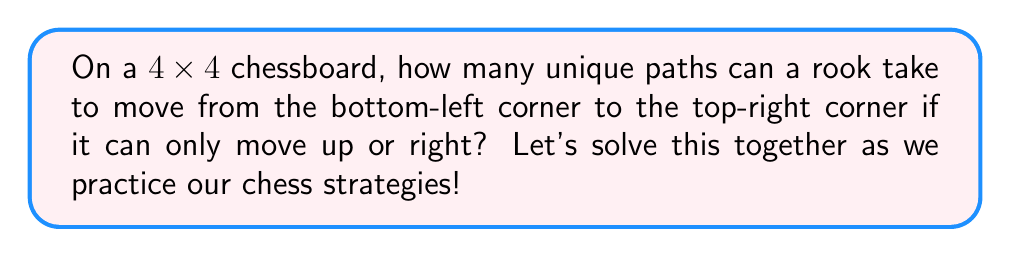Could you help me with this problem? Let's approach this step-by-step:

1) First, let's visualize the chessboard:

[asy]
size(100);
for(int i=0; i<4; ++i)
  for(int j=0; j<4; ++j)
    draw((i,j)--(i+1,j)--(i+1,j+1)--(i,j+1)--cycle);
dot((0,0), red);
dot((3,3), red);
label("Start", (0,0), SW);
label("End", (3,3), NE);
[/asy]

2) To reach the top-right corner from the bottom-left, the rook must move:
   - 3 steps right
   - 3 steps up

3) The total number of steps is always 6 (3 right + 3 up).

4) The question is essentially asking: in how many ways can we arrange 3 right moves and 3 up moves?

5) This is a combination problem. We need to choose 3 positions out of 6 for the right moves (or equivalently, for the up moves).

6) The formula for this combination is:

   $$\binom{6}{3} = \frac{6!}{3!(6-3)!} = \frac{6!}{3!3!}$$

7) Let's calculate:
   $$\frac{6 \times 5 \times 4 \times 3!}{3 \times 2 \times 1 \times 3!} = \frac{120}{6} = 20$$

Therefore, there are 20 unique paths the rook can take.
Answer: 20 